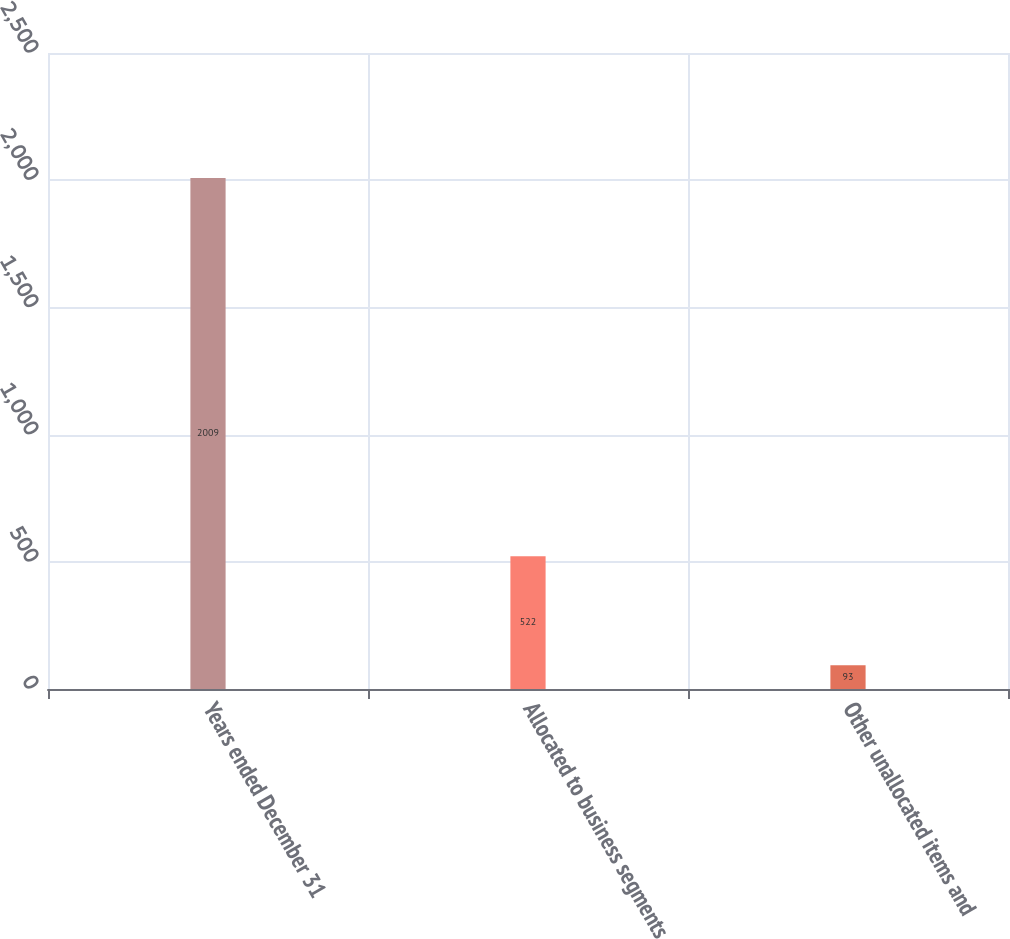<chart> <loc_0><loc_0><loc_500><loc_500><bar_chart><fcel>Years ended December 31<fcel>Allocated to business segments<fcel>Other unallocated items and<nl><fcel>2009<fcel>522<fcel>93<nl></chart> 